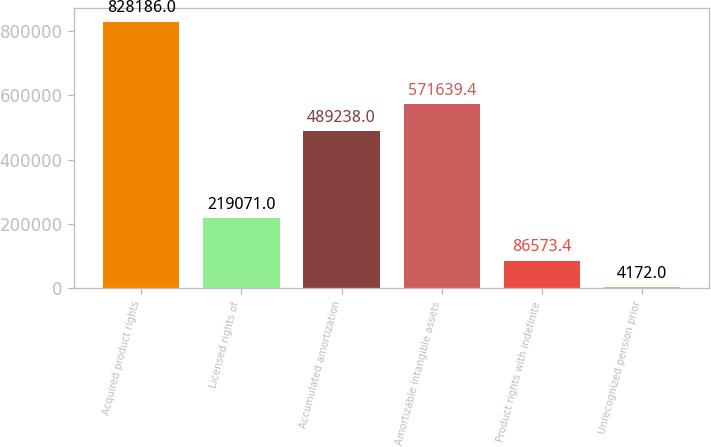Convert chart to OTSL. <chart><loc_0><loc_0><loc_500><loc_500><bar_chart><fcel>Acquired product rights<fcel>Licensed rights of<fcel>Accumulated amortization<fcel>Amortizable intangible assets<fcel>Product rights with indefinite<fcel>Unrecognized pension prior<nl><fcel>828186<fcel>219071<fcel>489238<fcel>571639<fcel>86573.4<fcel>4172<nl></chart> 